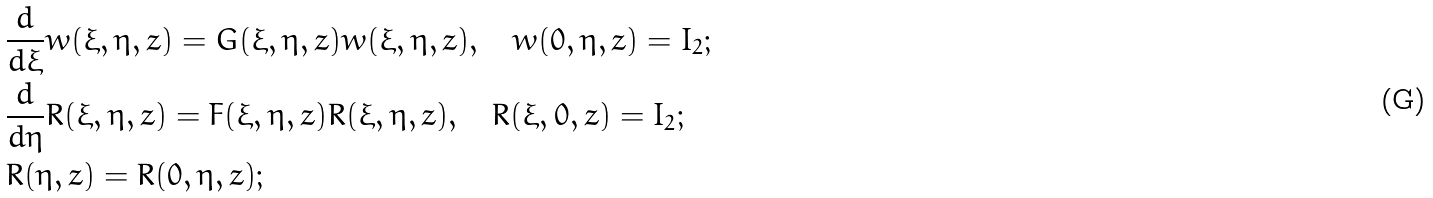<formula> <loc_0><loc_0><loc_500><loc_500>& \frac { d } { d \xi } w ( \xi , \eta , z ) = G ( \xi , \eta , z ) w ( \xi , \eta , z ) , \quad w ( 0 , \eta , z ) = I _ { 2 } ; \\ & \frac { d } { d \eta } R ( \xi , \eta , z ) = F ( \xi , \eta , z ) R ( \xi , \eta , z ) , \quad R ( \xi , 0 , z ) = I _ { 2 } ; \\ & R ( \eta , z ) = R ( 0 , \eta , z ) ;</formula> 